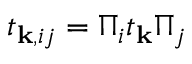Convert formula to latex. <formula><loc_0><loc_0><loc_500><loc_500>\begin{array} { r } { t _ { k , i j } = \Pi _ { i } t _ { k } \Pi _ { j } } \end{array}</formula> 